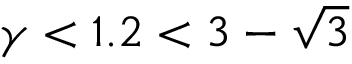<formula> <loc_0><loc_0><loc_500><loc_500>\gamma < 1 . 2 < 3 - \sqrt { 3 }</formula> 